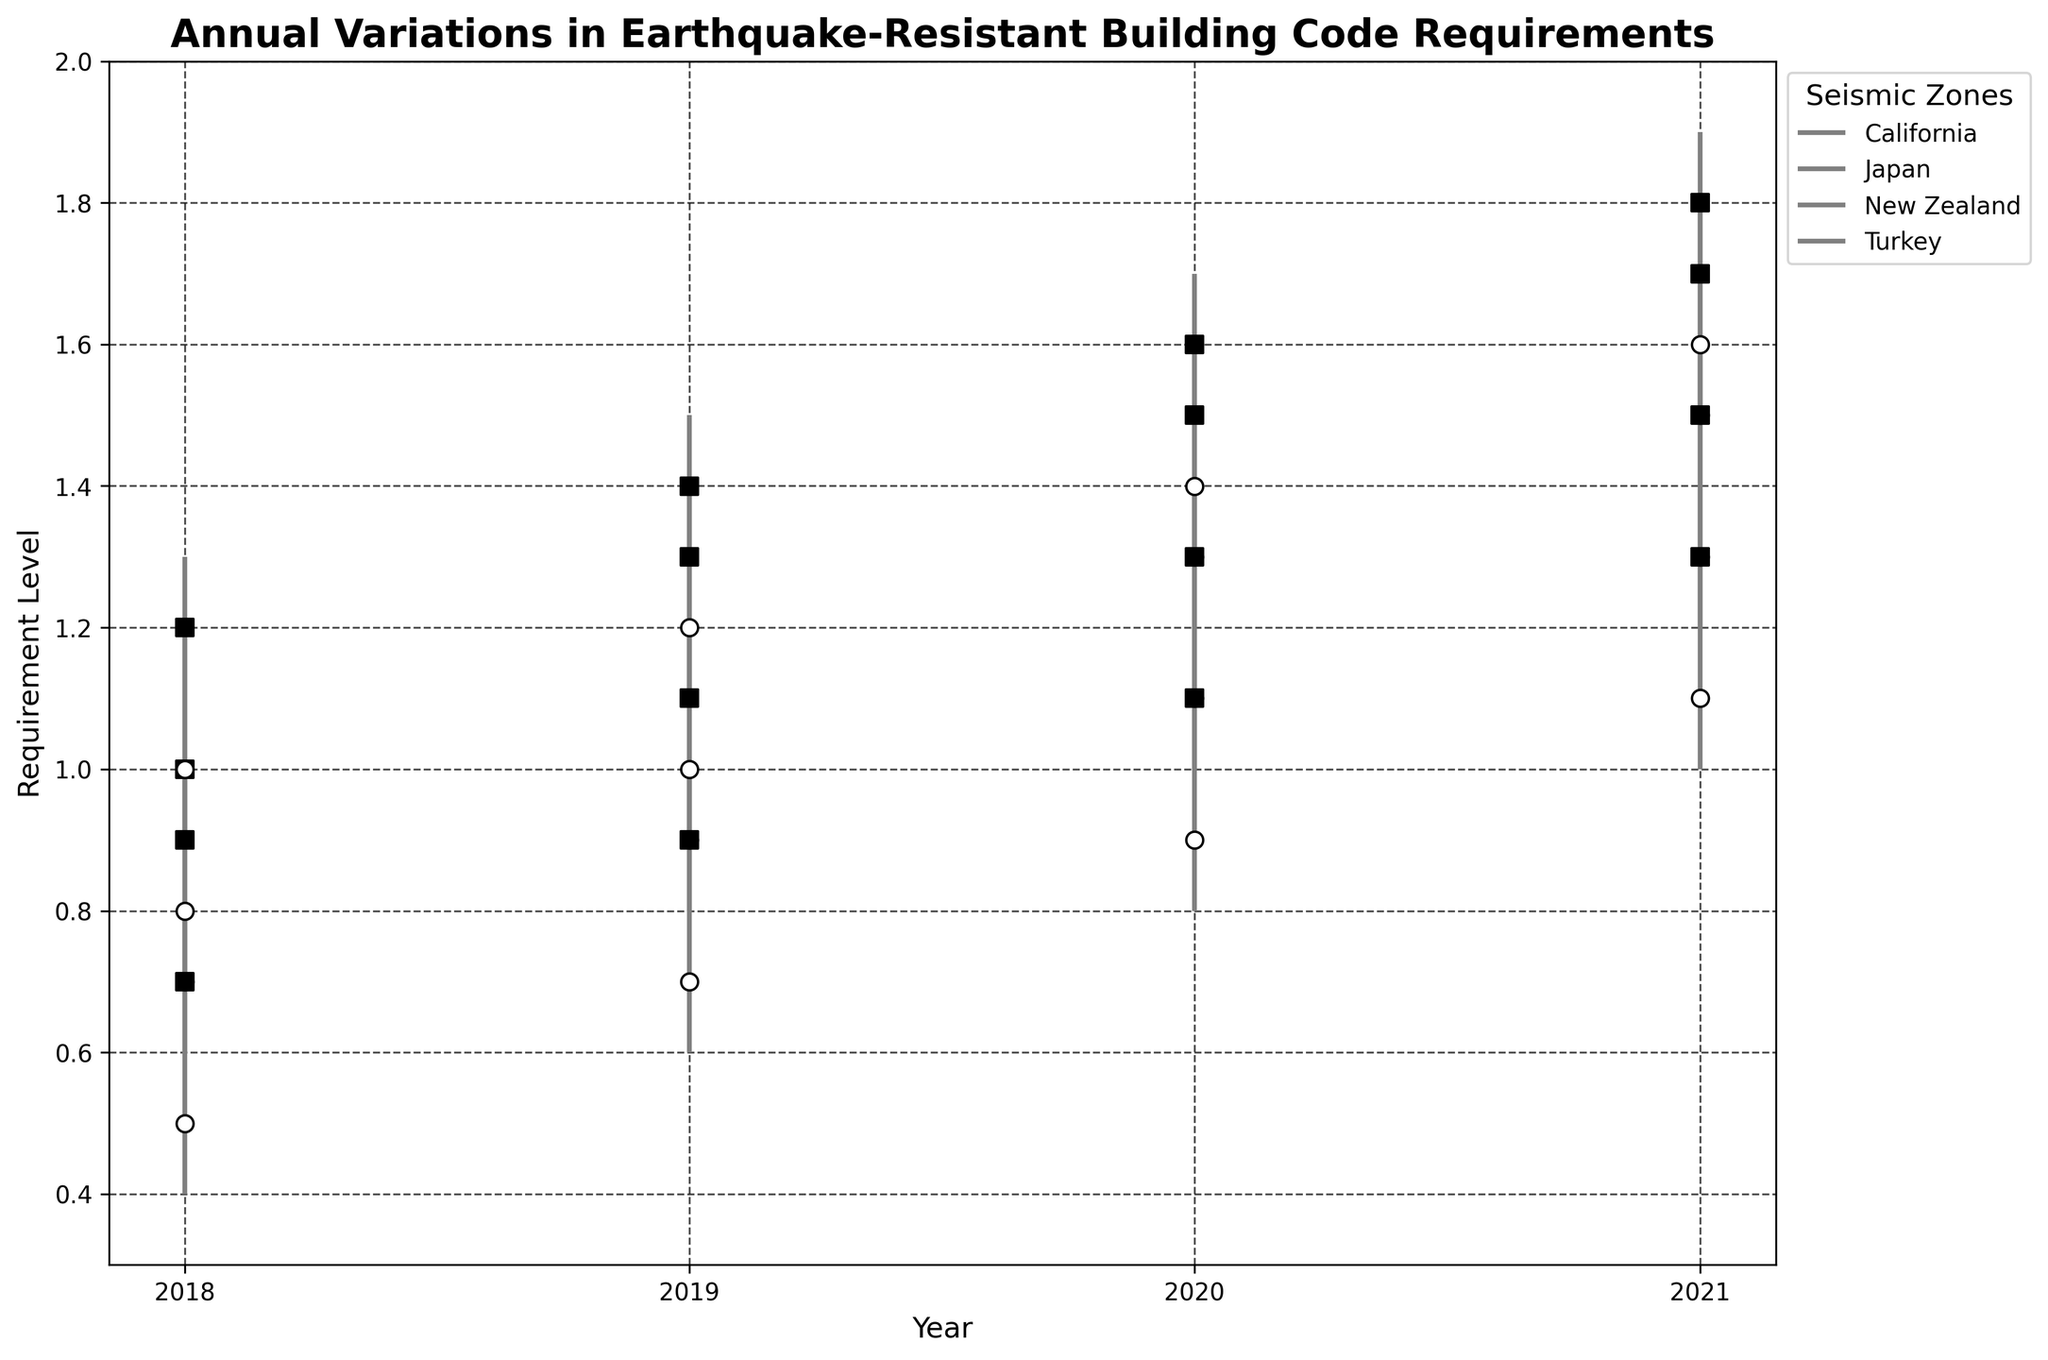What is the title of the chart? The title is located at the top of the chart in bold font, giving an overview of what the chart represents.
Answer: Annual Variations in Earthquake-Resistant Building Code Requirements Which seismic zone had the highest requirement level in 2021? Looking at the highest points on the vertical lines representing HighRequirements for each zone in 2021.
Answer: Japan How many years are displayed on the x-axis? By counting the distinct year markers along the x-axis of the chart.
Answer: 4 What is the requirement level range for Turkey in 2020? Checking the vertical line for Turkey in 2020 and noting the LowRequirement and HighRequirement values.
Answer: 0.8 to 1.2 Compare the opening requirement levels for California and Japan in 2019. Which one is higher? Comparing the OpenRequirement values for California and Japan in 2019.
Answer: Japan What is the average CloseRequirement level for New Zealand over the years displayed? Summing the CloseRequirement values for New Zealand over the years and dividing by the number of years (4). Calculation: (0.9 + 1.1 + 1.3 + 1.5) / 4
Answer: 1.20 Which zone showed the most significant increase in CloseRequirement levels from 2018 to 2019? Calculating the difference between the CloseRequirement levels for 2018 and 2019 for each zone and identifying the maximum increase. Detailed difference calculations:
  - California: 1.3 - 1.0 = 0.3
  - Japan: 1.4 - 1.2 = 0.2
  - New Zealand: 1.1 - 0.9 = 0.2
  - Turkey: 0.9 - 0.7 = 0.2
Answer: California What pattern is observed in the CloseRequirement levels for Japan from 2018 to 2021? Noting the CloseRequirement values for Japan for each year and analyzing the trend across these years.
Answer: Increasing Which year had the highest average HighRequirement level across all zones? Calculating the average HighRequirement for each year and comparing them. Detailed calculations:
  - 2018: (1.2 + 1.3 + 1.0 + 0.8) / 4 = 1.075
  - 2019: (1.4 + 1.5 + 1.2 + 1.0) / 4 = 1.275
  - 2020: (1.6 + 1.7 + 1.4 + 1.2) / 4 = 1.475
  - 2021: (1.8 + 1.9 + 1.6 + 1.4) / 4 = 1.675
Answer: 2021 How much did the OpenRequirement level for New Zealand change from 2018 to 2021? Subtracting the OpenRequirement level for 2018 from the OpenRequirement level for 2021 for New Zealand. Calculation: 1.3 - 0.7 = 0.6
Answer: 0.6 